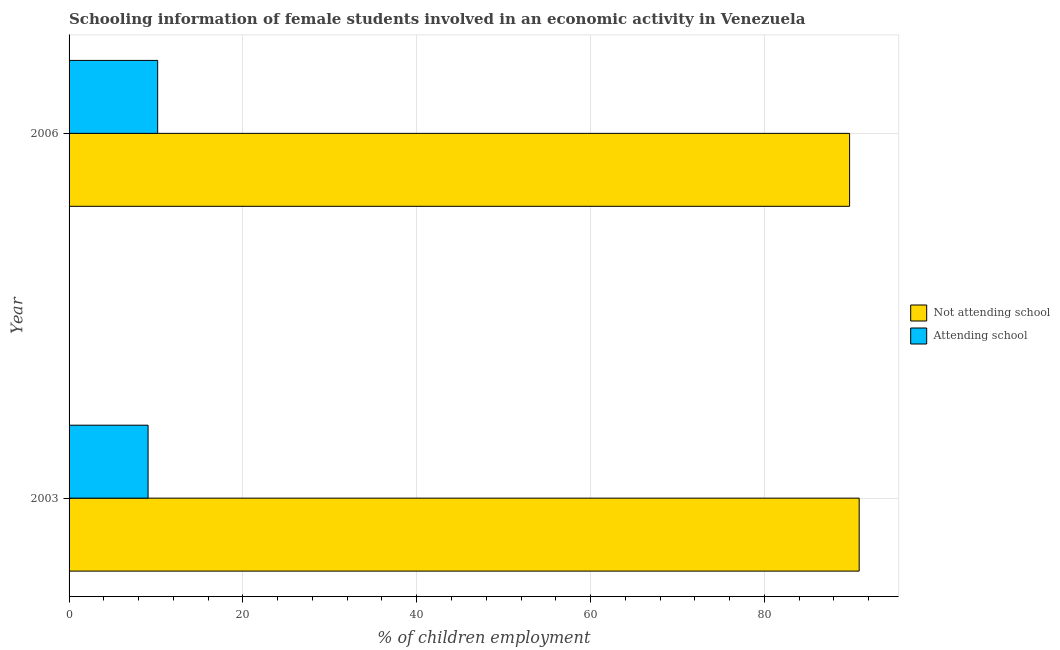How many different coloured bars are there?
Give a very brief answer. 2. How many groups of bars are there?
Make the answer very short. 2. Are the number of bars per tick equal to the number of legend labels?
Provide a short and direct response. Yes. What is the label of the 1st group of bars from the top?
Offer a terse response. 2006. In how many cases, is the number of bars for a given year not equal to the number of legend labels?
Your response must be concise. 0. What is the percentage of employed females who are attending school in 2006?
Provide a succinct answer. 10.19. Across all years, what is the maximum percentage of employed females who are not attending school?
Provide a succinct answer. 90.91. Across all years, what is the minimum percentage of employed females who are not attending school?
Your answer should be compact. 89.81. In which year was the percentage of employed females who are attending school maximum?
Offer a terse response. 2006. In which year was the percentage of employed females who are attending school minimum?
Provide a succinct answer. 2003. What is the total percentage of employed females who are not attending school in the graph?
Give a very brief answer. 180.72. What is the difference between the percentage of employed females who are attending school in 2003 and that in 2006?
Your answer should be compact. -1.1. What is the difference between the percentage of employed females who are not attending school in 2003 and the percentage of employed females who are attending school in 2006?
Offer a very short reply. 80.72. What is the average percentage of employed females who are attending school per year?
Your answer should be very brief. 9.64. In the year 2003, what is the difference between the percentage of employed females who are attending school and percentage of employed females who are not attending school?
Your answer should be very brief. -81.82. What is the ratio of the percentage of employed females who are attending school in 2003 to that in 2006?
Provide a succinct answer. 0.89. What does the 2nd bar from the top in 2003 represents?
Provide a succinct answer. Not attending school. What does the 1st bar from the bottom in 2006 represents?
Keep it short and to the point. Not attending school. Are all the bars in the graph horizontal?
Your response must be concise. Yes. Are the values on the major ticks of X-axis written in scientific E-notation?
Make the answer very short. No. Where does the legend appear in the graph?
Ensure brevity in your answer.  Center right. How many legend labels are there?
Keep it short and to the point. 2. How are the legend labels stacked?
Provide a short and direct response. Vertical. What is the title of the graph?
Your answer should be compact. Schooling information of female students involved in an economic activity in Venezuela. Does "Short-term debt" appear as one of the legend labels in the graph?
Your answer should be compact. No. What is the label or title of the X-axis?
Offer a very short reply. % of children employment. What is the % of children employment of Not attending school in 2003?
Offer a terse response. 90.91. What is the % of children employment in Attending school in 2003?
Provide a short and direct response. 9.09. What is the % of children employment of Not attending school in 2006?
Keep it short and to the point. 89.81. What is the % of children employment of Attending school in 2006?
Make the answer very short. 10.19. Across all years, what is the maximum % of children employment in Not attending school?
Make the answer very short. 90.91. Across all years, what is the maximum % of children employment in Attending school?
Offer a very short reply. 10.19. Across all years, what is the minimum % of children employment of Not attending school?
Provide a succinct answer. 89.81. Across all years, what is the minimum % of children employment in Attending school?
Offer a terse response. 9.09. What is the total % of children employment of Not attending school in the graph?
Your answer should be very brief. 180.72. What is the total % of children employment in Attending school in the graph?
Your answer should be compact. 19.29. What is the difference between the % of children employment in Not attending school in 2003 and that in 2006?
Provide a short and direct response. 1.1. What is the difference between the % of children employment of Attending school in 2003 and that in 2006?
Keep it short and to the point. -1.1. What is the difference between the % of children employment of Not attending school in 2003 and the % of children employment of Attending school in 2006?
Your response must be concise. 80.72. What is the average % of children employment of Not attending school per year?
Ensure brevity in your answer.  90.36. What is the average % of children employment of Attending school per year?
Keep it short and to the point. 9.64. In the year 2003, what is the difference between the % of children employment of Not attending school and % of children employment of Attending school?
Provide a succinct answer. 81.82. In the year 2006, what is the difference between the % of children employment in Not attending school and % of children employment in Attending school?
Your answer should be compact. 79.61. What is the ratio of the % of children employment in Not attending school in 2003 to that in 2006?
Offer a very short reply. 1.01. What is the ratio of the % of children employment in Attending school in 2003 to that in 2006?
Your answer should be very brief. 0.89. What is the difference between the highest and the second highest % of children employment of Not attending school?
Provide a short and direct response. 1.1. What is the difference between the highest and the second highest % of children employment in Attending school?
Your answer should be compact. 1.1. What is the difference between the highest and the lowest % of children employment of Not attending school?
Ensure brevity in your answer.  1.1. What is the difference between the highest and the lowest % of children employment in Attending school?
Provide a short and direct response. 1.1. 